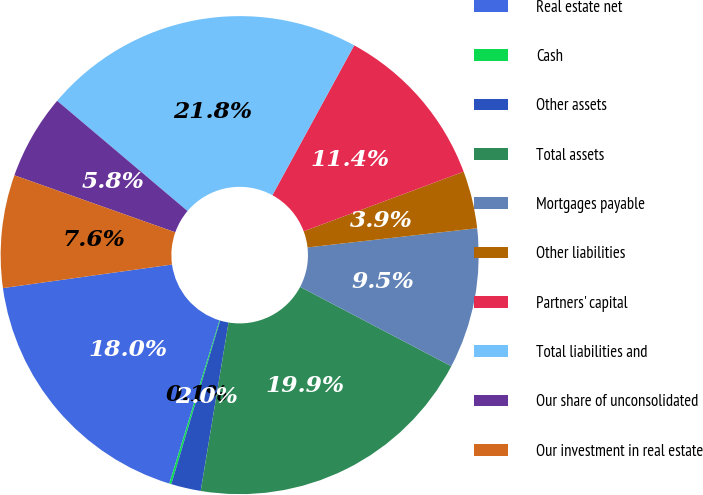<chart> <loc_0><loc_0><loc_500><loc_500><pie_chart><fcel>Real estate net<fcel>Cash<fcel>Other assets<fcel>Total assets<fcel>Mortgages payable<fcel>Other liabilities<fcel>Partners' capital<fcel>Total liabilities and<fcel>Our share of unconsolidated<fcel>Our investment in real estate<nl><fcel>18.04%<fcel>0.14%<fcel>2.01%<fcel>19.91%<fcel>9.49%<fcel>3.88%<fcel>11.37%<fcel>21.78%<fcel>5.75%<fcel>7.62%<nl></chart> 